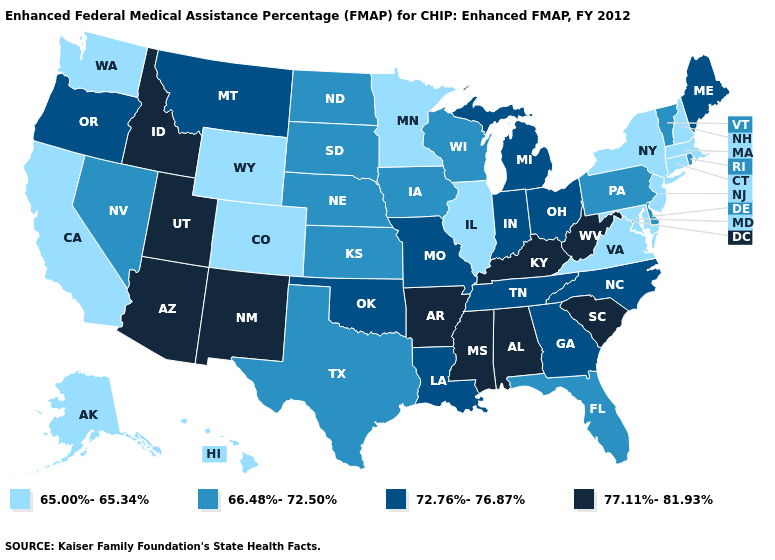What is the value of Connecticut?
Give a very brief answer. 65.00%-65.34%. Name the states that have a value in the range 66.48%-72.50%?
Write a very short answer. Delaware, Florida, Iowa, Kansas, Nebraska, Nevada, North Dakota, Pennsylvania, Rhode Island, South Dakota, Texas, Vermont, Wisconsin. Name the states that have a value in the range 66.48%-72.50%?
Be succinct. Delaware, Florida, Iowa, Kansas, Nebraska, Nevada, North Dakota, Pennsylvania, Rhode Island, South Dakota, Texas, Vermont, Wisconsin. Name the states that have a value in the range 66.48%-72.50%?
Concise answer only. Delaware, Florida, Iowa, Kansas, Nebraska, Nevada, North Dakota, Pennsylvania, Rhode Island, South Dakota, Texas, Vermont, Wisconsin. What is the value of Massachusetts?
Concise answer only. 65.00%-65.34%. Name the states that have a value in the range 66.48%-72.50%?
Give a very brief answer. Delaware, Florida, Iowa, Kansas, Nebraska, Nevada, North Dakota, Pennsylvania, Rhode Island, South Dakota, Texas, Vermont, Wisconsin. Which states have the highest value in the USA?
Keep it brief. Alabama, Arizona, Arkansas, Idaho, Kentucky, Mississippi, New Mexico, South Carolina, Utah, West Virginia. What is the lowest value in states that border Delaware?
Answer briefly. 65.00%-65.34%. Is the legend a continuous bar?
Concise answer only. No. What is the lowest value in the South?
Write a very short answer. 65.00%-65.34%. Name the states that have a value in the range 65.00%-65.34%?
Quick response, please. Alaska, California, Colorado, Connecticut, Hawaii, Illinois, Maryland, Massachusetts, Minnesota, New Hampshire, New Jersey, New York, Virginia, Washington, Wyoming. What is the value of Massachusetts?
Give a very brief answer. 65.00%-65.34%. Does Maine have a lower value than Oregon?
Be succinct. No. Name the states that have a value in the range 66.48%-72.50%?
Give a very brief answer. Delaware, Florida, Iowa, Kansas, Nebraska, Nevada, North Dakota, Pennsylvania, Rhode Island, South Dakota, Texas, Vermont, Wisconsin. 